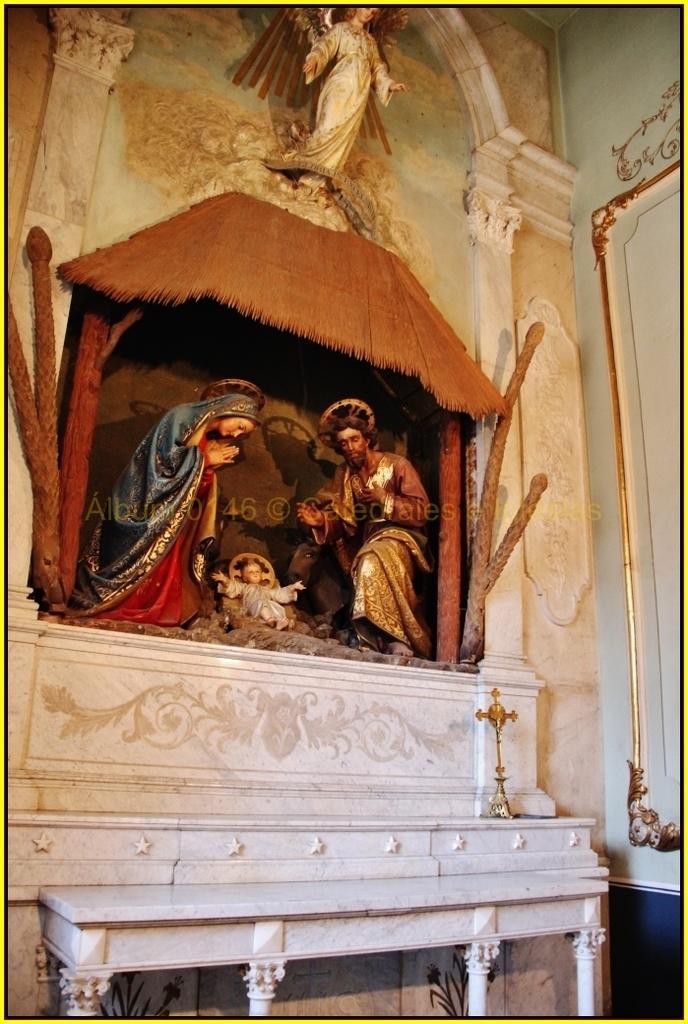Please provide a concise description of this image. This picture seems to be clicked inside. In the center we can see the sculpture of a man and a woman and we can see the sculpture of a baby lying on the ground and at the top we can see the sculpture of a person attached to the wall and we can see there are some objects. 